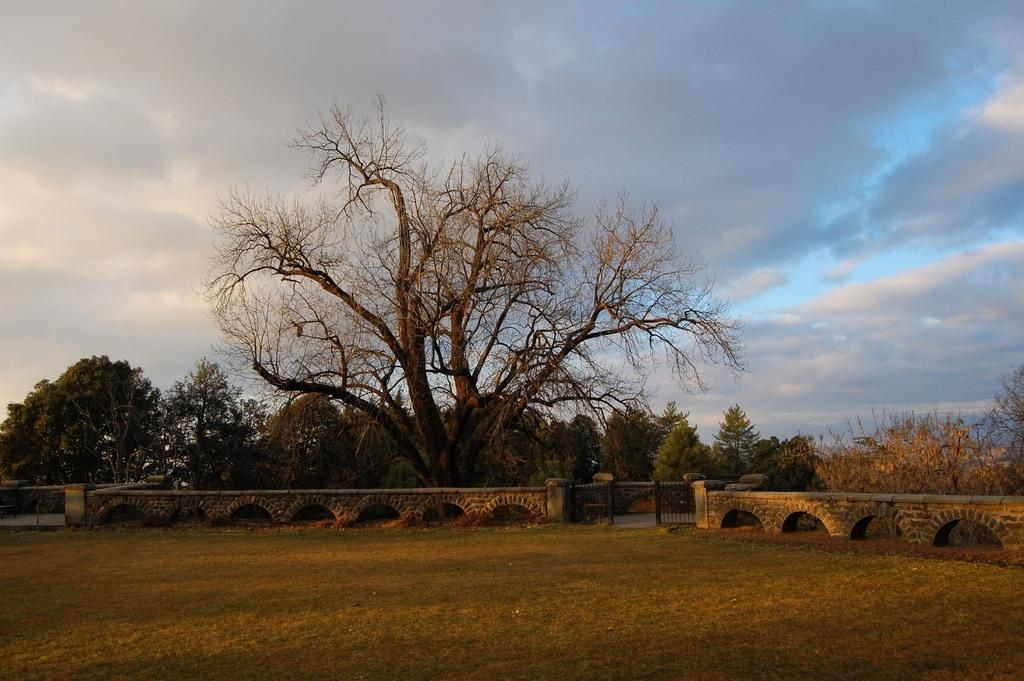What type of vegetation is present in the image? There are trees in the image. What type of barrier can be seen in the image? There is a fence in the image. What is the specific type of entrance in the image? There is a metal gate in the image. How would you describe the sky in the image? The sky is blue and cloudy in the image. What type of ground surface is visible in the image? There is grass on the ground in the image. What type of dress is the tree wearing in the image? Trees do not wear dresses, so this question is not applicable to the image. 